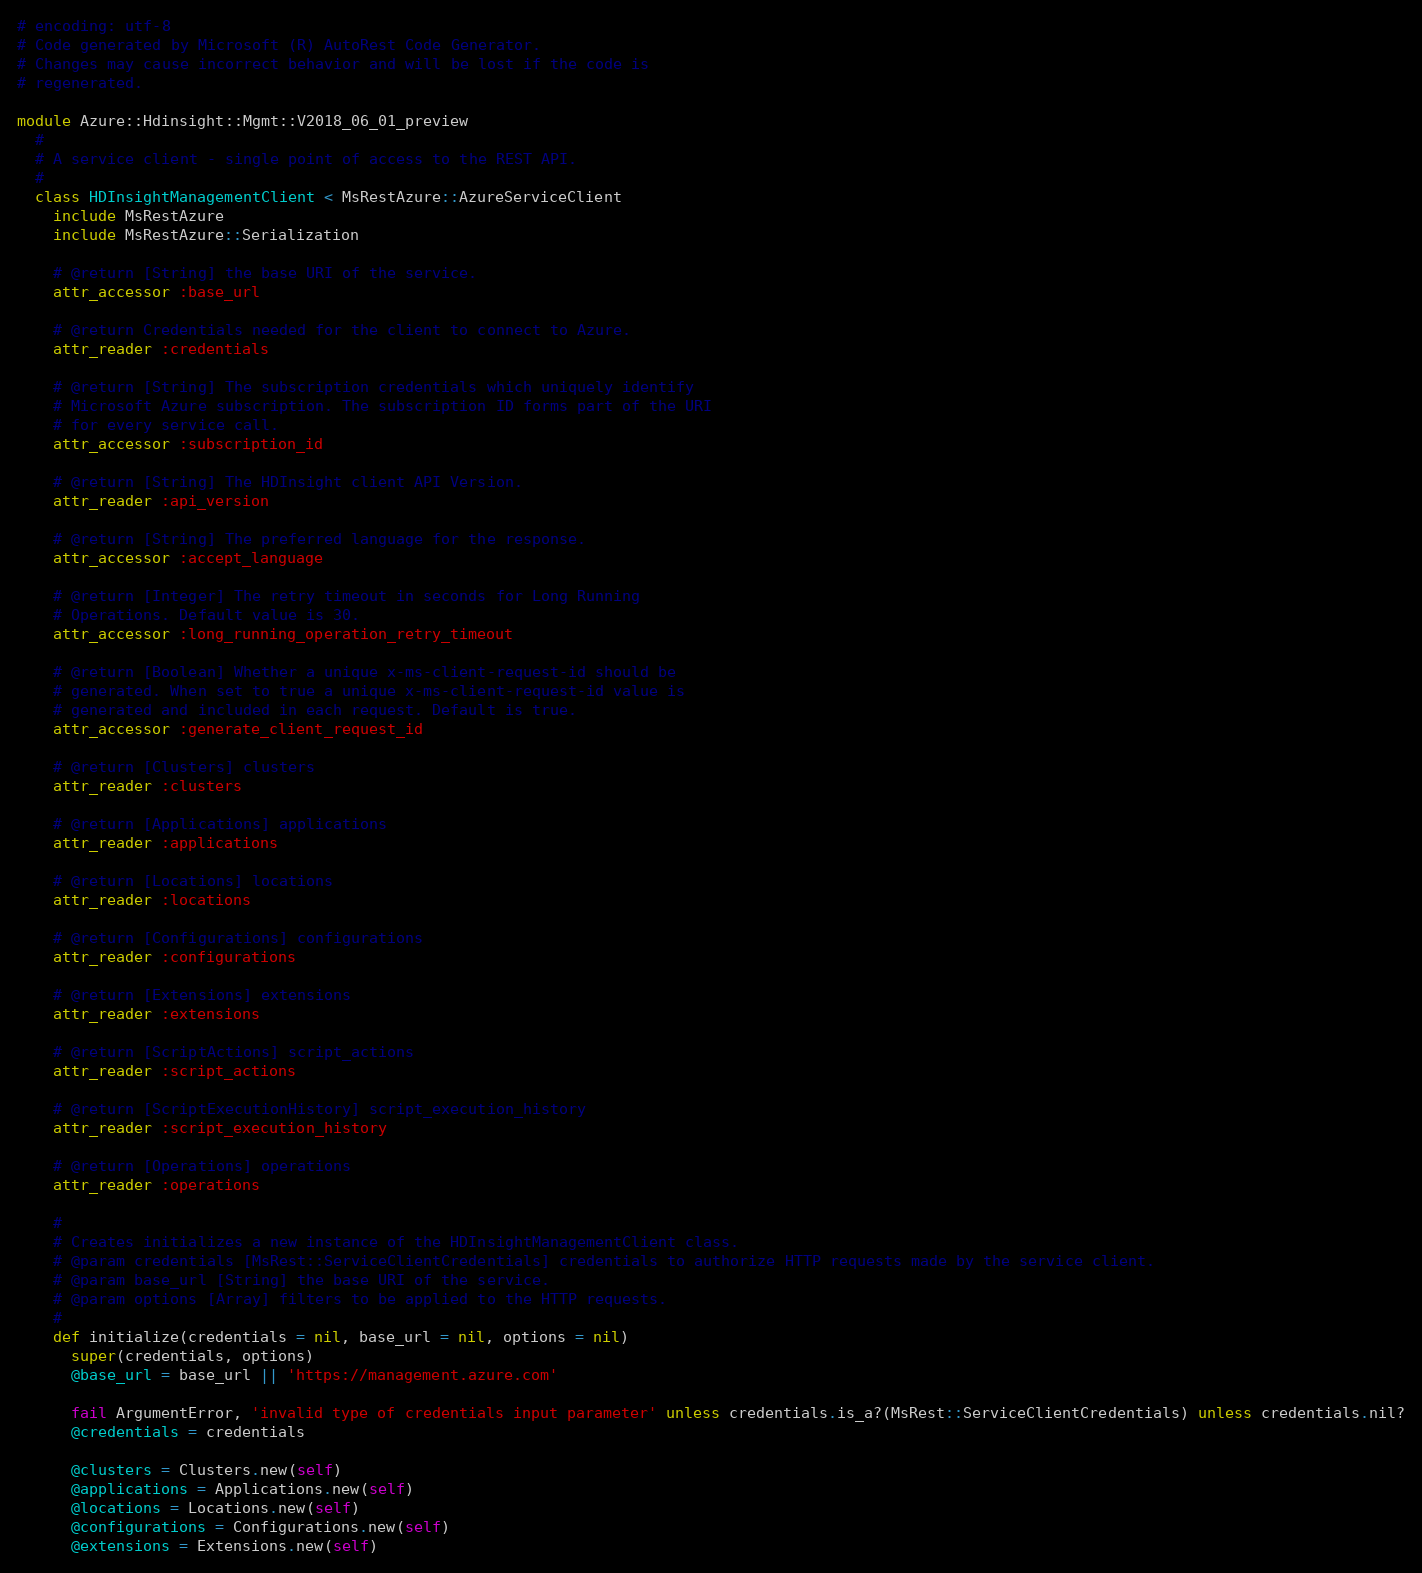<code> <loc_0><loc_0><loc_500><loc_500><_Ruby_># encoding: utf-8
# Code generated by Microsoft (R) AutoRest Code Generator.
# Changes may cause incorrect behavior and will be lost if the code is
# regenerated.

module Azure::Hdinsight::Mgmt::V2018_06_01_preview
  #
  # A service client - single point of access to the REST API.
  #
  class HDInsightManagementClient < MsRestAzure::AzureServiceClient
    include MsRestAzure
    include MsRestAzure::Serialization

    # @return [String] the base URI of the service.
    attr_accessor :base_url

    # @return Credentials needed for the client to connect to Azure.
    attr_reader :credentials

    # @return [String] The subscription credentials which uniquely identify
    # Microsoft Azure subscription. The subscription ID forms part of the URI
    # for every service call.
    attr_accessor :subscription_id

    # @return [String] The HDInsight client API Version.
    attr_reader :api_version

    # @return [String] The preferred language for the response.
    attr_accessor :accept_language

    # @return [Integer] The retry timeout in seconds for Long Running
    # Operations. Default value is 30.
    attr_accessor :long_running_operation_retry_timeout

    # @return [Boolean] Whether a unique x-ms-client-request-id should be
    # generated. When set to true a unique x-ms-client-request-id value is
    # generated and included in each request. Default is true.
    attr_accessor :generate_client_request_id

    # @return [Clusters] clusters
    attr_reader :clusters

    # @return [Applications] applications
    attr_reader :applications

    # @return [Locations] locations
    attr_reader :locations

    # @return [Configurations] configurations
    attr_reader :configurations

    # @return [Extensions] extensions
    attr_reader :extensions

    # @return [ScriptActions] script_actions
    attr_reader :script_actions

    # @return [ScriptExecutionHistory] script_execution_history
    attr_reader :script_execution_history

    # @return [Operations] operations
    attr_reader :operations

    #
    # Creates initializes a new instance of the HDInsightManagementClient class.
    # @param credentials [MsRest::ServiceClientCredentials] credentials to authorize HTTP requests made by the service client.
    # @param base_url [String] the base URI of the service.
    # @param options [Array] filters to be applied to the HTTP requests.
    #
    def initialize(credentials = nil, base_url = nil, options = nil)
      super(credentials, options)
      @base_url = base_url || 'https://management.azure.com'

      fail ArgumentError, 'invalid type of credentials input parameter' unless credentials.is_a?(MsRest::ServiceClientCredentials) unless credentials.nil?
      @credentials = credentials

      @clusters = Clusters.new(self)
      @applications = Applications.new(self)
      @locations = Locations.new(self)
      @configurations = Configurations.new(self)
      @extensions = Extensions.new(self)</code> 